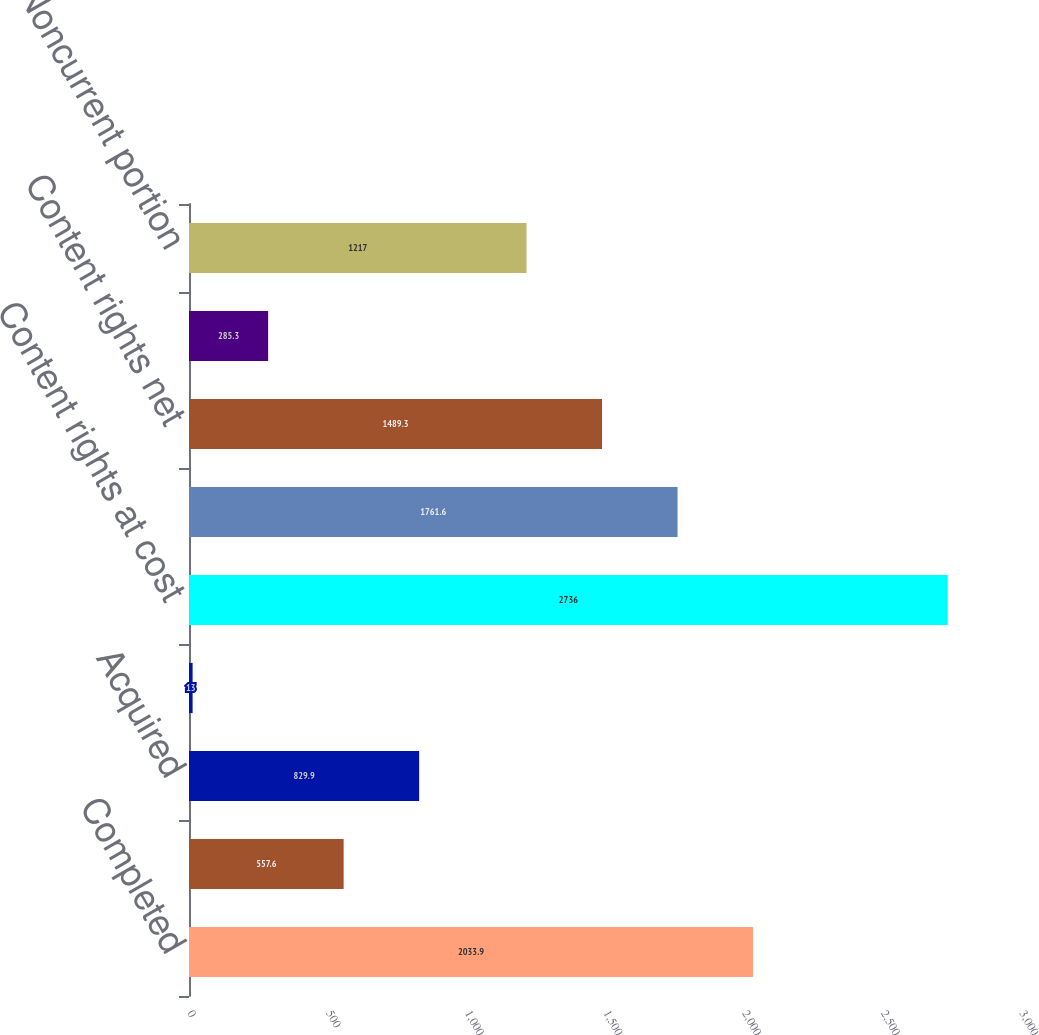Convert chart. <chart><loc_0><loc_0><loc_500><loc_500><bar_chart><fcel>Completed<fcel>In-production<fcel>Acquired<fcel>Prepaid<fcel>Content rights at cost<fcel>Accumulated amortization<fcel>Content rights net<fcel>Less current portion<fcel>Noncurrent portion<nl><fcel>2033.9<fcel>557.6<fcel>829.9<fcel>13<fcel>2736<fcel>1761.6<fcel>1489.3<fcel>285.3<fcel>1217<nl></chart> 